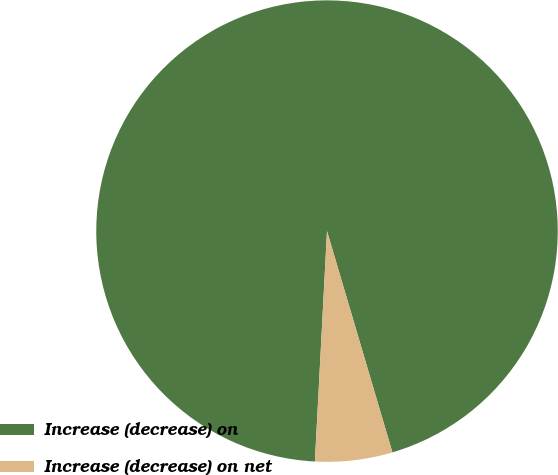Convert chart to OTSL. <chart><loc_0><loc_0><loc_500><loc_500><pie_chart><fcel>Increase (decrease) on<fcel>Increase (decrease) on net<nl><fcel>94.59%<fcel>5.41%<nl></chart> 